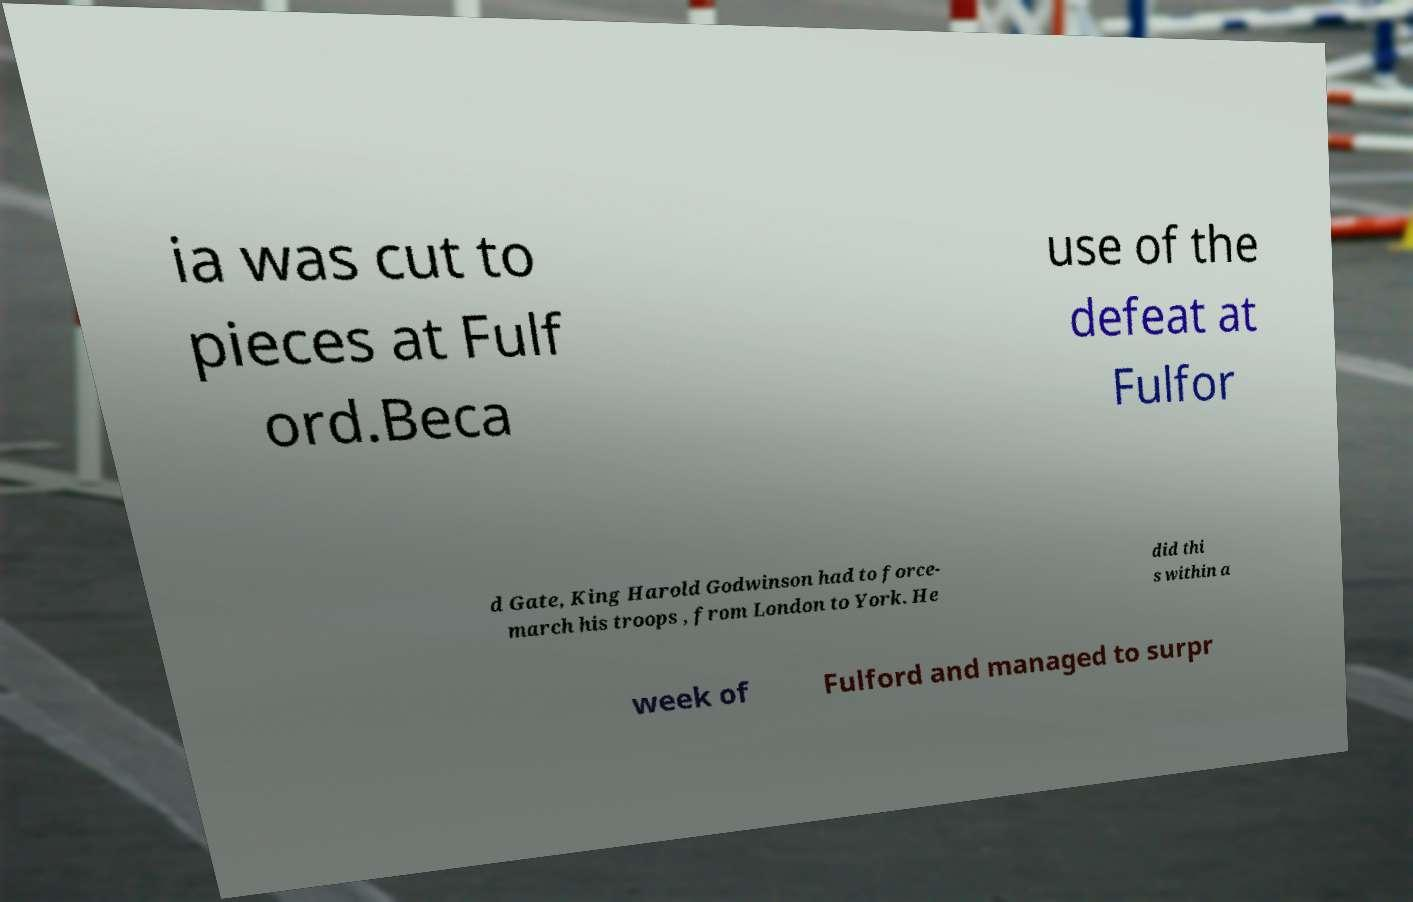There's text embedded in this image that I need extracted. Can you transcribe it verbatim? ia was cut to pieces at Fulf ord.Beca use of the defeat at Fulfor d Gate, King Harold Godwinson had to force- march his troops , from London to York. He did thi s within a week of Fulford and managed to surpr 